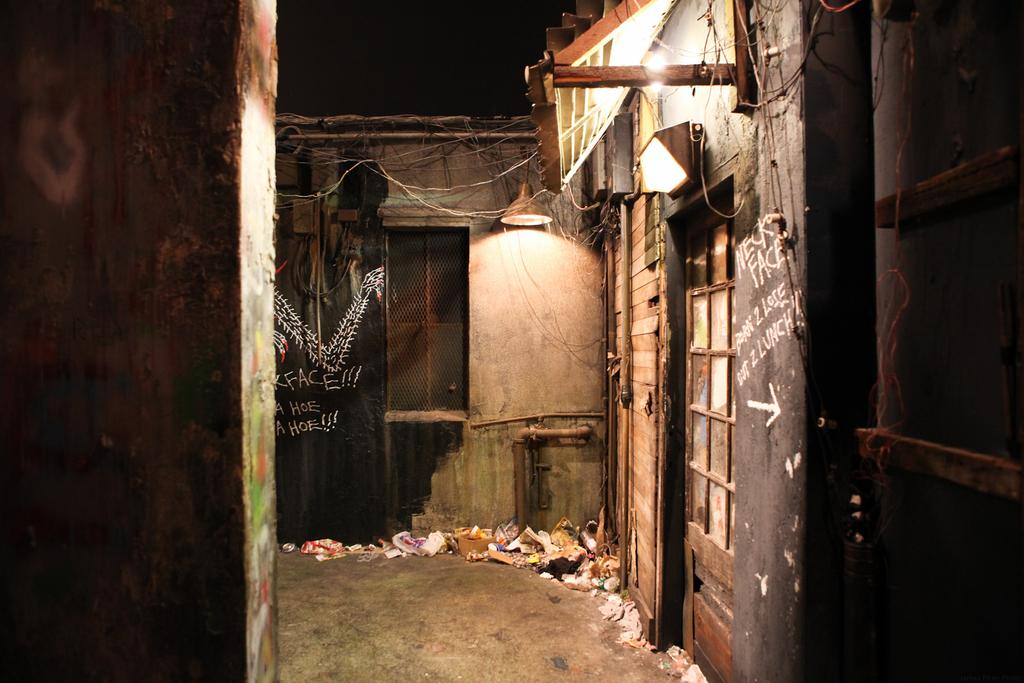What type of structure is visible in the image? There is a house in the image. How many lamps can be seen in the image? There are two lamps in the image. What is present on the ground in the image? There is garbage on the ground in the image. Who is the creator of the milk depicted in the image? There is no milk present in the image, so it is not possible to determine the creator. 